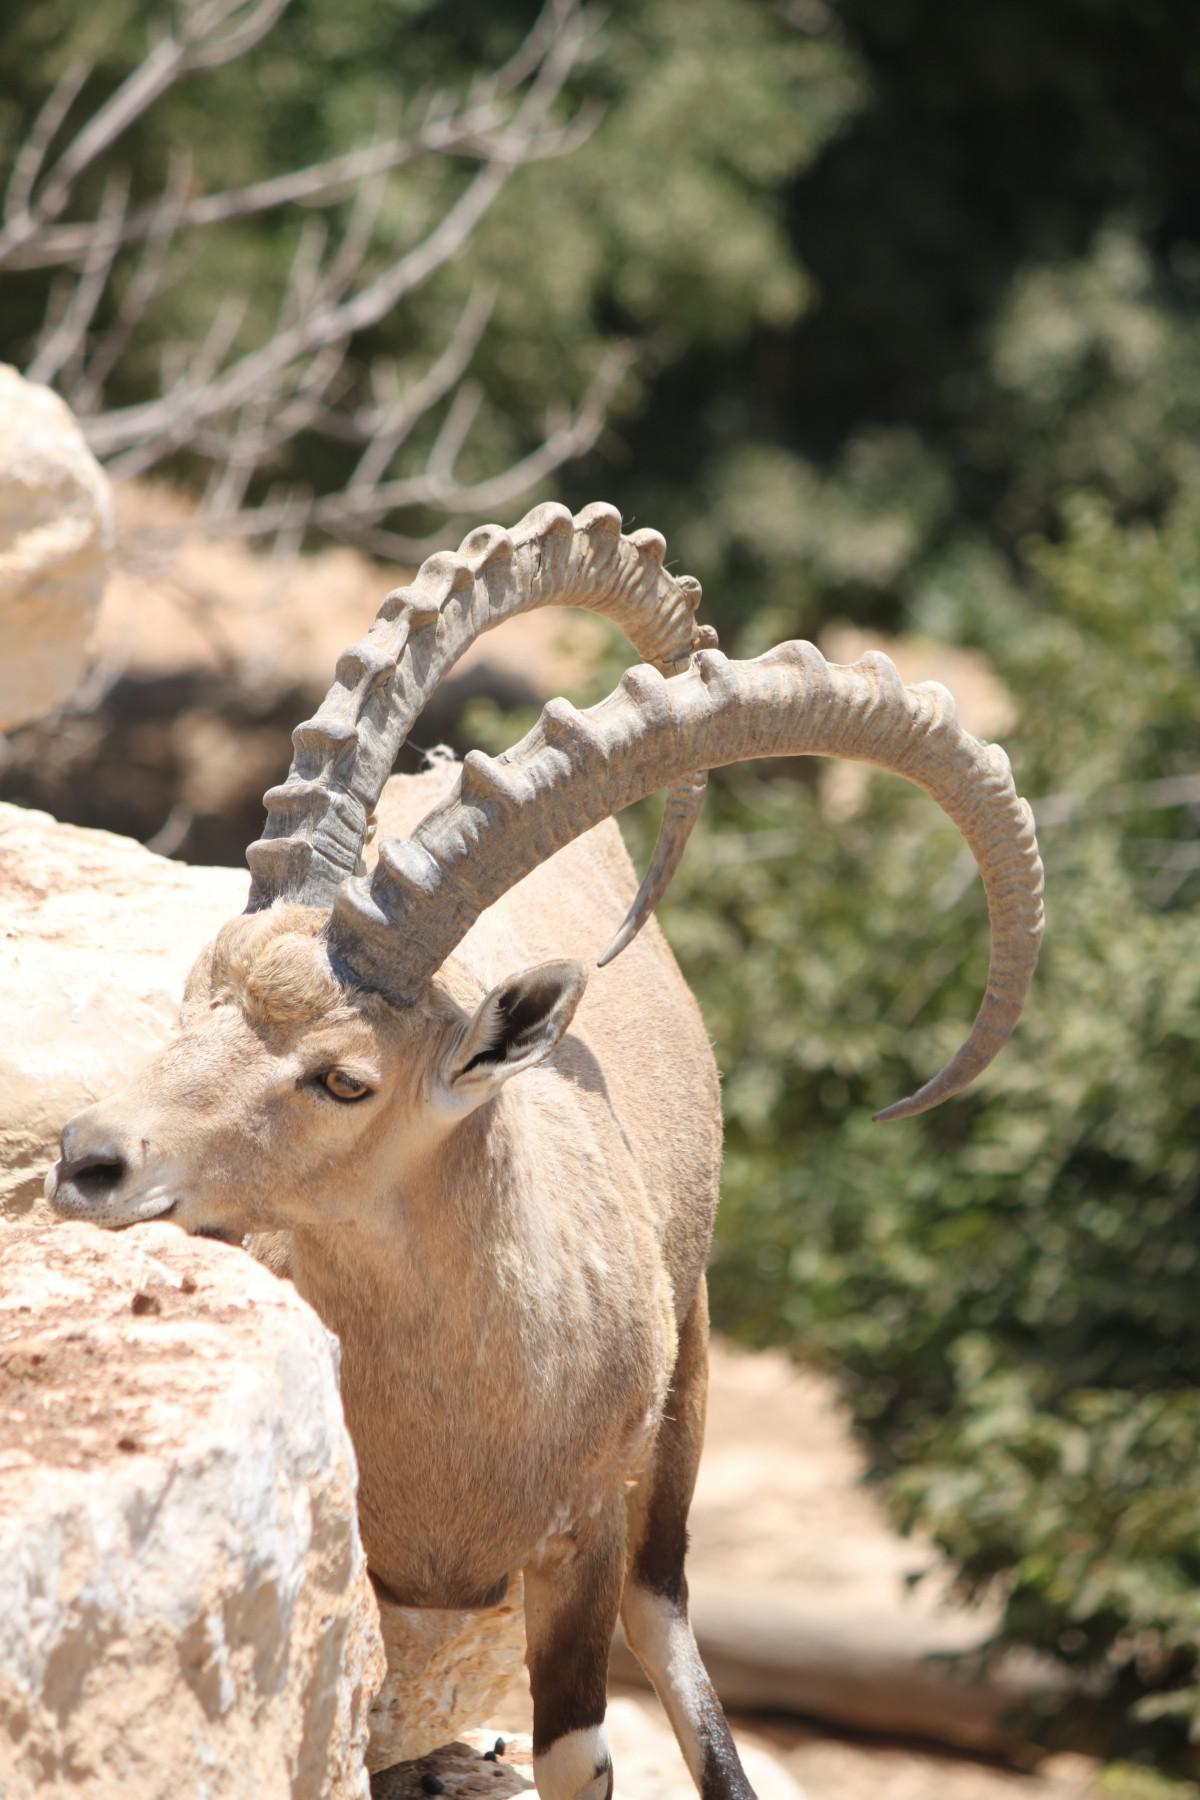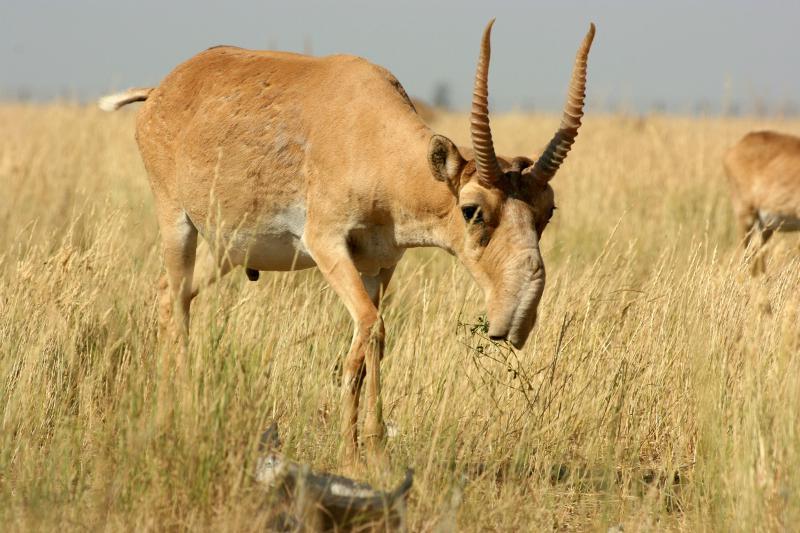The first image is the image on the left, the second image is the image on the right. For the images shown, is this caption "The right image contains two animals standing on a rock." true? Answer yes or no. No. The first image is the image on the left, the second image is the image on the right. Assess this claim about the two images: "An image shows two horned animals facing toward each other on a stony slope.". Correct or not? Answer yes or no. No. 